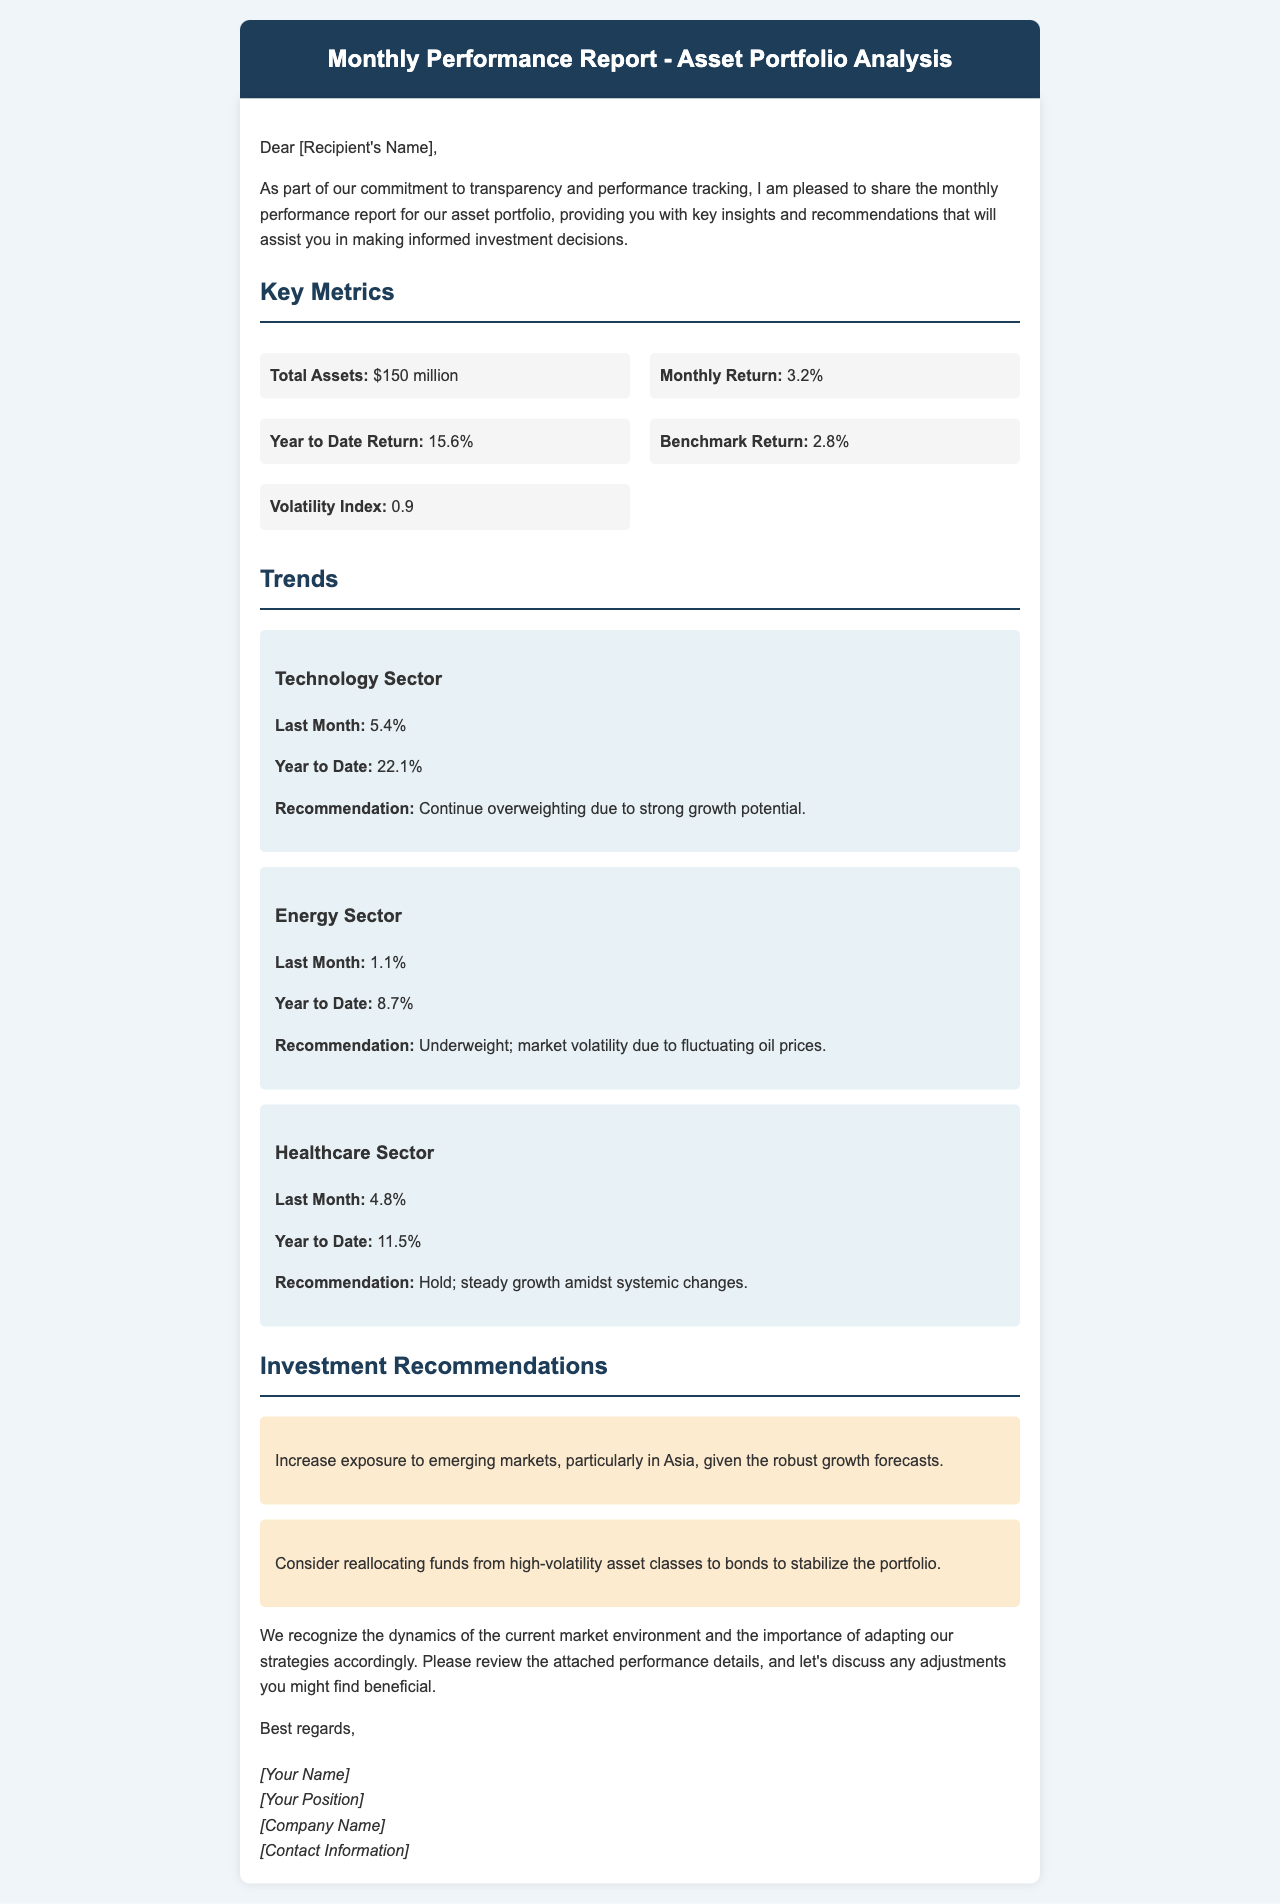What is the total assets? The total assets listed in the report are $150 million.
Answer: $150 million What is the monthly return? The report specifies the monthly return as 3.2%.
Answer: 3.2% What was the last month's return for the Technology Sector? The Technology Sector's return for the last month is 5.4%.
Answer: 5.4% What is the recommendation for the Energy Sector? The report recommends to underweight the Energy Sector due to market volatility.
Answer: Underweight What is the Year to Date Return? The Year to Date Return reported is 15.6%.
Answer: 15.6% How much should exposure to emerging markets be increased? The report suggests increasing exposure but does not specify an amount; it highlights robust growth forecasts.
Answer: Increase exposure What is the volatility index? The volatility index indicated in the report is 0.9.
Answer: 0.9 What is the recommendation for the Healthcare Sector? The recommendation for the Healthcare Sector is to hold.
Answer: Hold What is the title of the document? The title stated in the document is "Monthly Performance Report - Asset Portfolio Analysis".
Answer: Monthly Performance Report - Asset Portfolio Analysis 